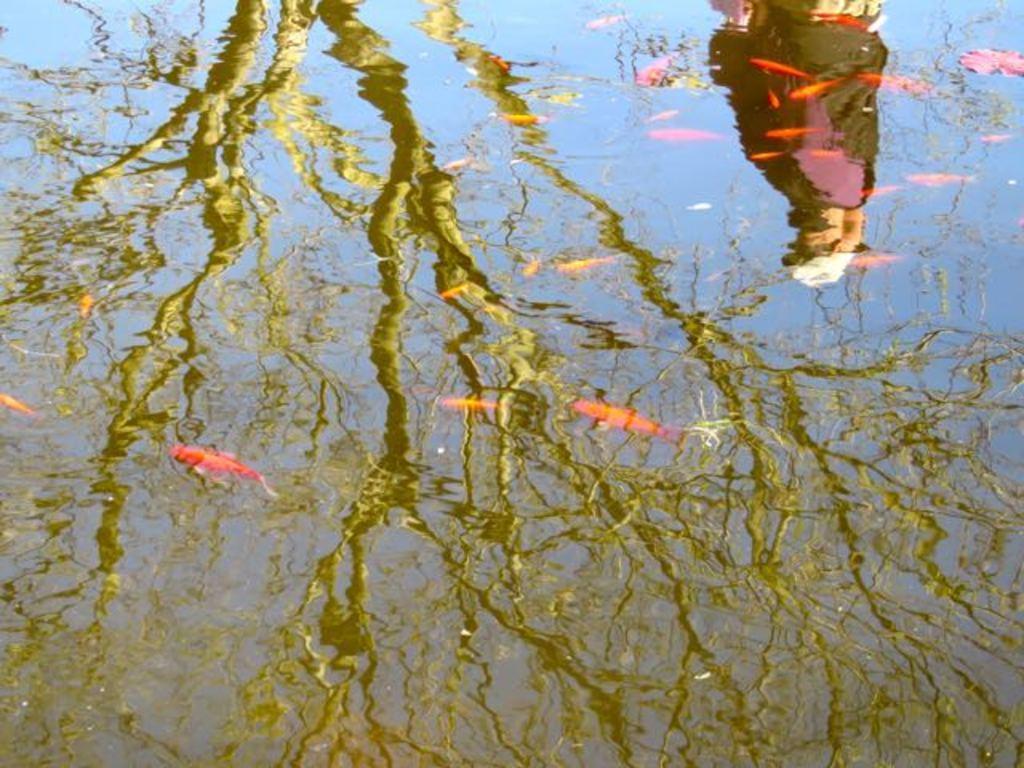How would you summarize this image in a sentence or two? This is water. In the reflection we can see trees and a person. 